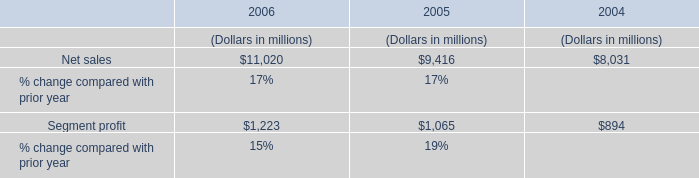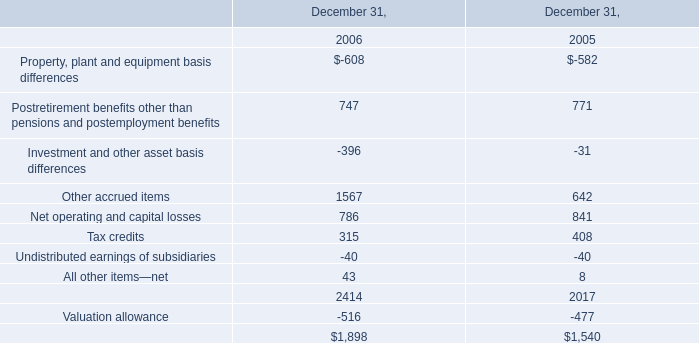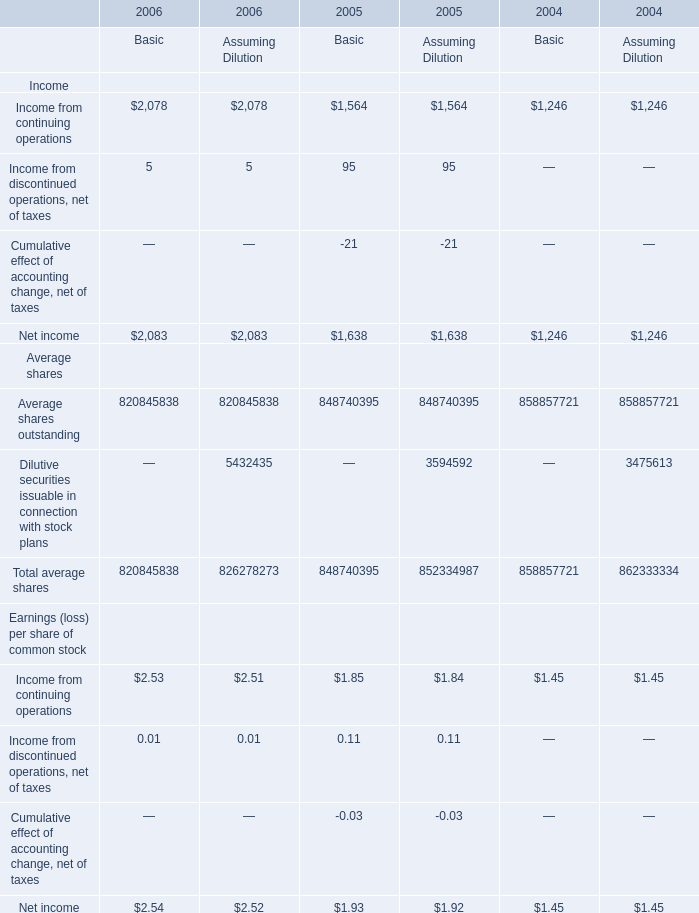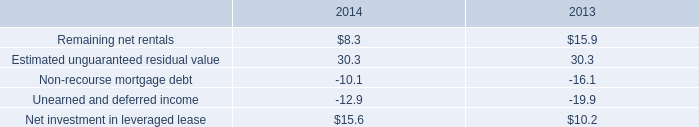what is the average net rentals for 2013-2014 , in millions? 
Computations: ((8.3 + 15.9) / 2)
Answer: 12.1. 